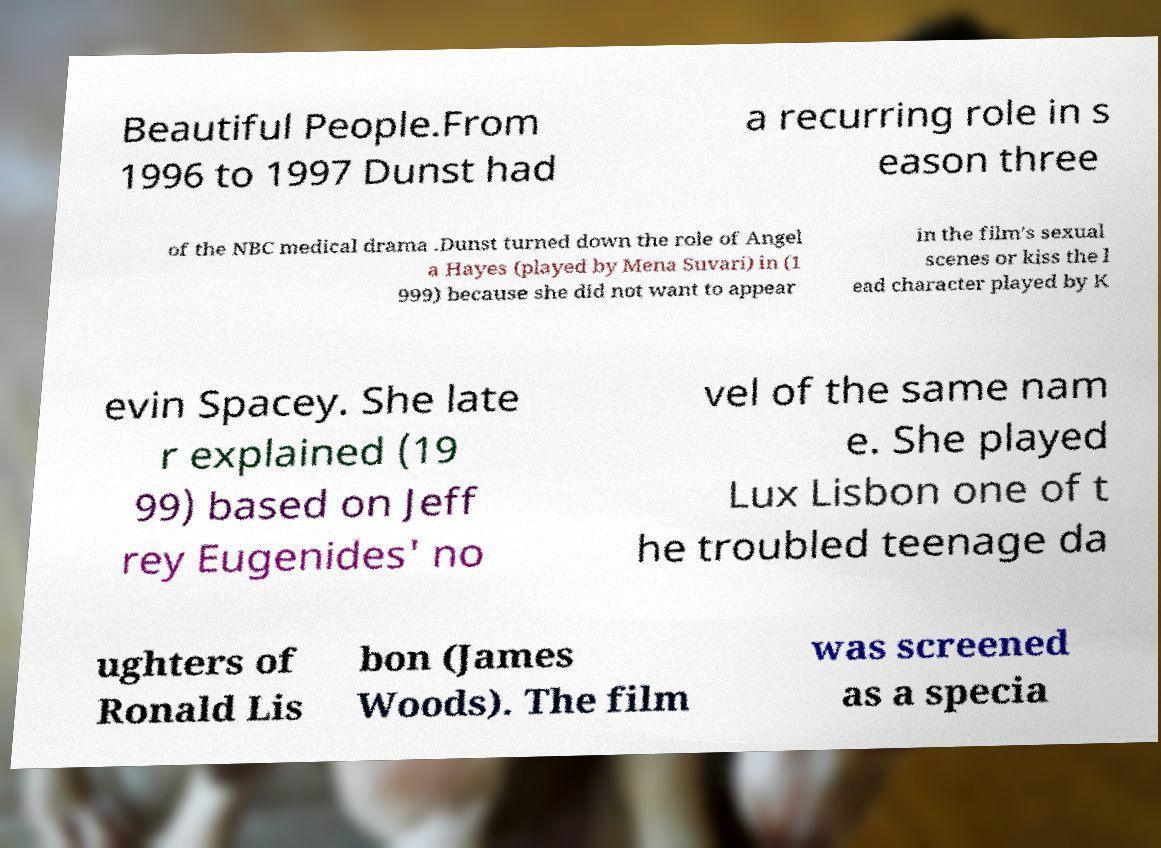I need the written content from this picture converted into text. Can you do that? Beautiful People.From 1996 to 1997 Dunst had a recurring role in s eason three of the NBC medical drama .Dunst turned down the role of Angel a Hayes (played by Mena Suvari) in (1 999) because she did not want to appear in the film's sexual scenes or kiss the l ead character played by K evin Spacey. She late r explained (19 99) based on Jeff rey Eugenides' no vel of the same nam e. She played Lux Lisbon one of t he troubled teenage da ughters of Ronald Lis bon (James Woods). The film was screened as a specia 